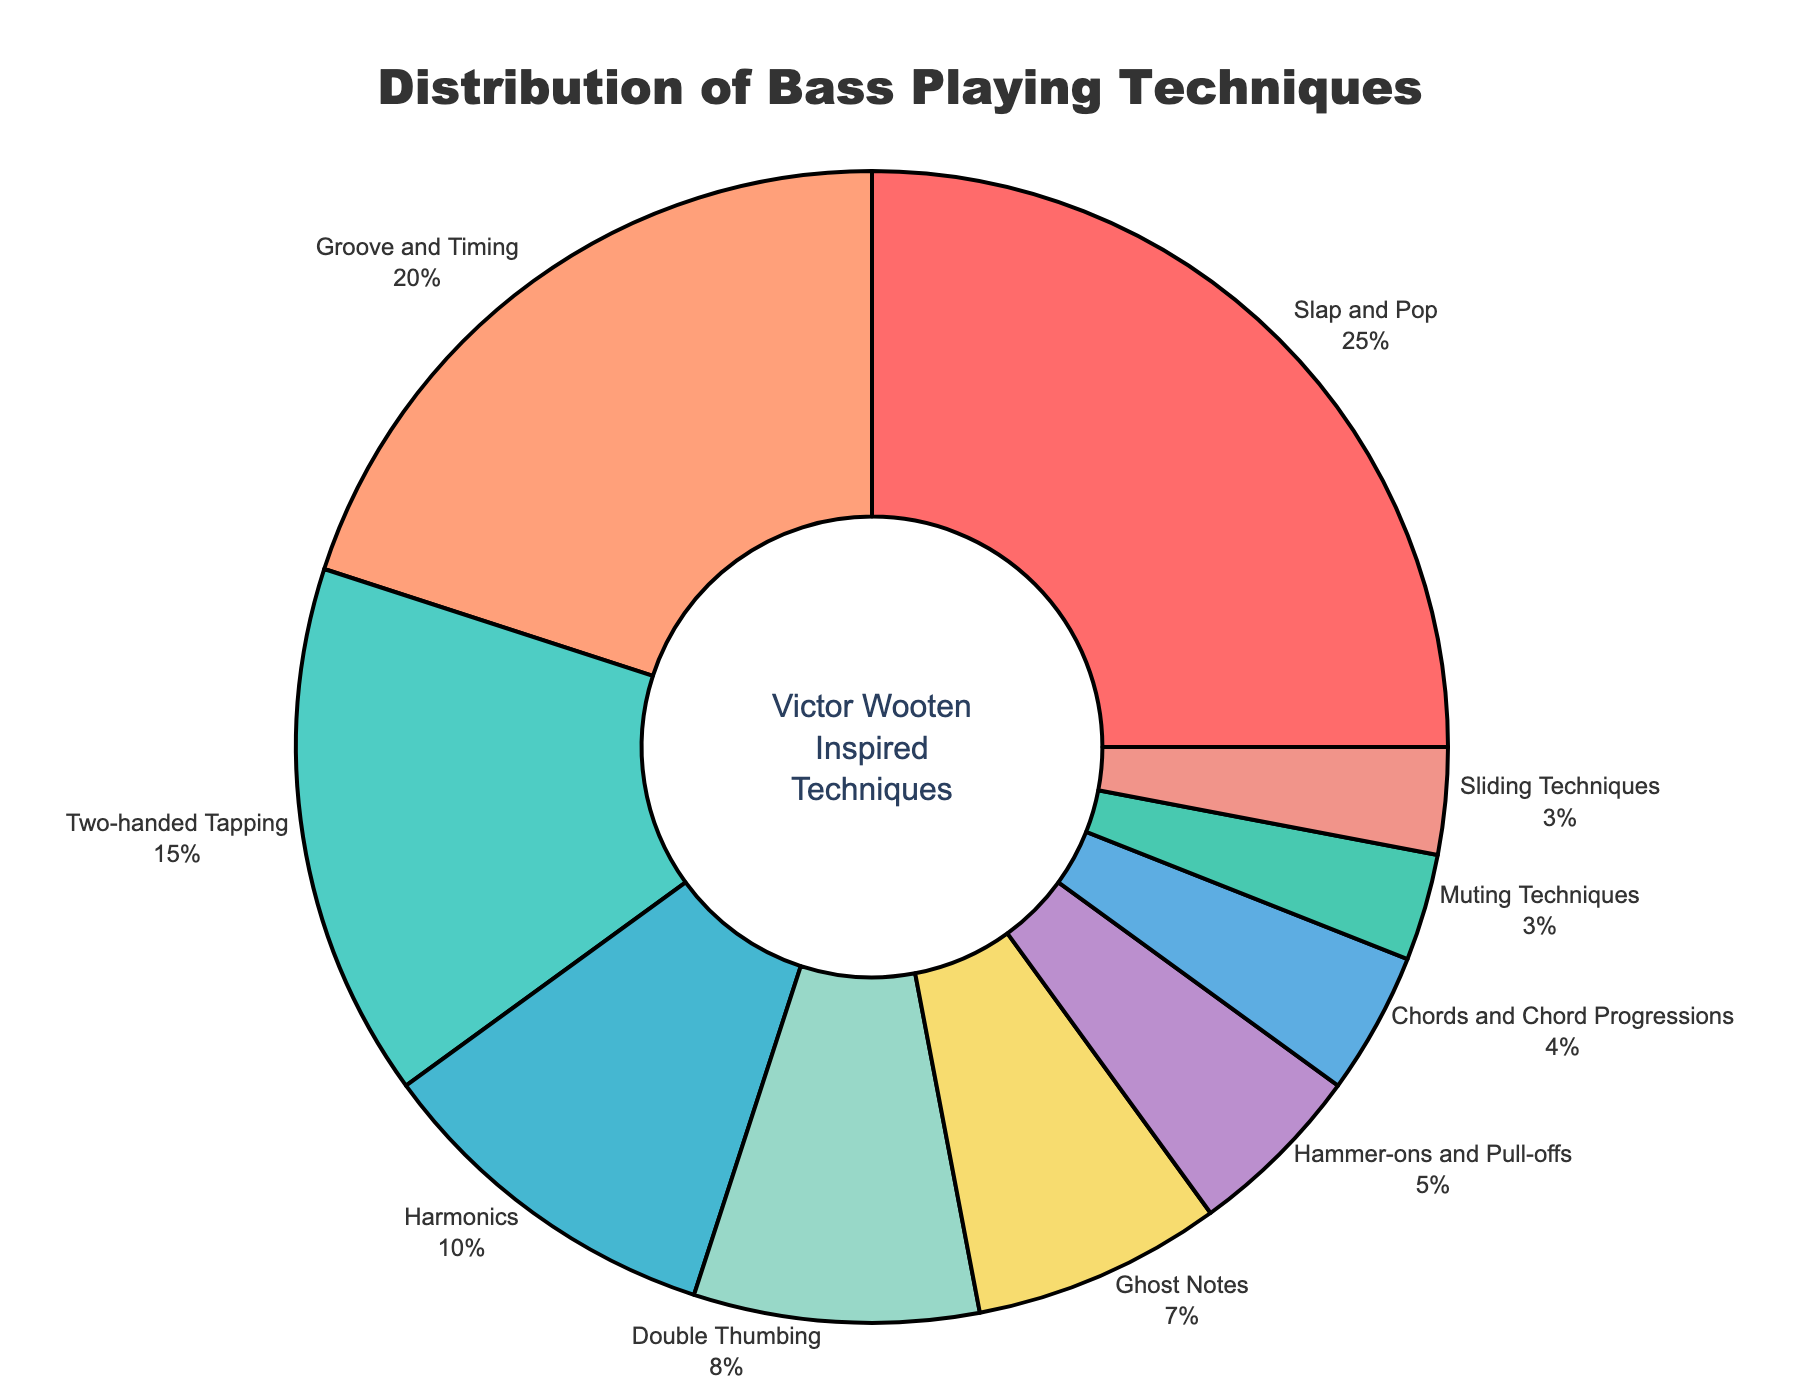Which technique occupies the largest portion of the pie chart? The technique with the highest percentage takes up the largest portion of the pie chart. According to the data, "Slap and Pop" has 25%, the highest value.
Answer: Slap and Pop Which techniques combined account for 50% of the distribution? Look at the two largest percentages in the chart. "Slap and Pop" is 25% and "Groove and Timing" is 20%. Their sum is 45%. Including the next highest, "Two-handed Tapping" at 15%, brings us to 60%, but that is more than 50%. So, we take the top two: 25% + 20% = 45%, and then slightly less with "Harmonics" adding 10%, brings us above 45%. Combine these iteratively to approximate 50%.
Answer: Slap and Pop, Groove and Timing, Two-handed Tapping By how much does "Groove and Timing" exceed "Harmonics"? "Groove and Timing" has a percentage of 20%, while "Harmonics" has 10%. Subtract the percentage of "Harmonics" from "Groove and Timing" to find the difference: 20% - 10% = 10%.
Answer: 10% Which three techniques have the smallest combined percentage, and what is their total? Identify the three smallest percentages: "Muting Techniques" (3%), "Sliding Techniques" (3%), and "Chords and Chord Progressions" (4%). Add their percentages: 3% + 3% + 4% = 10%.
Answer: Muting Techniques, Sliding Techniques, Chords and Chord Progressions; 10% Compare the percentage of "Double Thumbing" to "Ghost Notes" and state the difference. "Double Thumbing" is 8% and "Ghost Notes" is 7%. Subtract the lower percentage from the higher one: 8% - 7% = 1%.
Answer: 1% If you were to group "Slap and Pop", "Groove and Timing", and "Two-handed Tapping", what percentage would they represent in total? Add the percentages of "Slap and Pop" (25%), "Groove and Timing" (20%), and "Two-handed Tapping" (15%): 25% + 20% + 15% = 60%.
Answer: 60% Which technique is represented by the color red in the pie chart? Referring to the order of colors listed in the code, the first technique (Slap and Pop) would be red since it's the first color mentioned.
Answer: Slap and Pop Is the combined percentage of "Sliding Techniques" and "Muting Techniques" greater than that of "Harmonics"? "Sliding Techniques" and "Muting Techniques" each have 3%, so combined they are 3% + 3% = 6%. "Harmonics" has 10%, which is greater than 6%.
Answer: No 